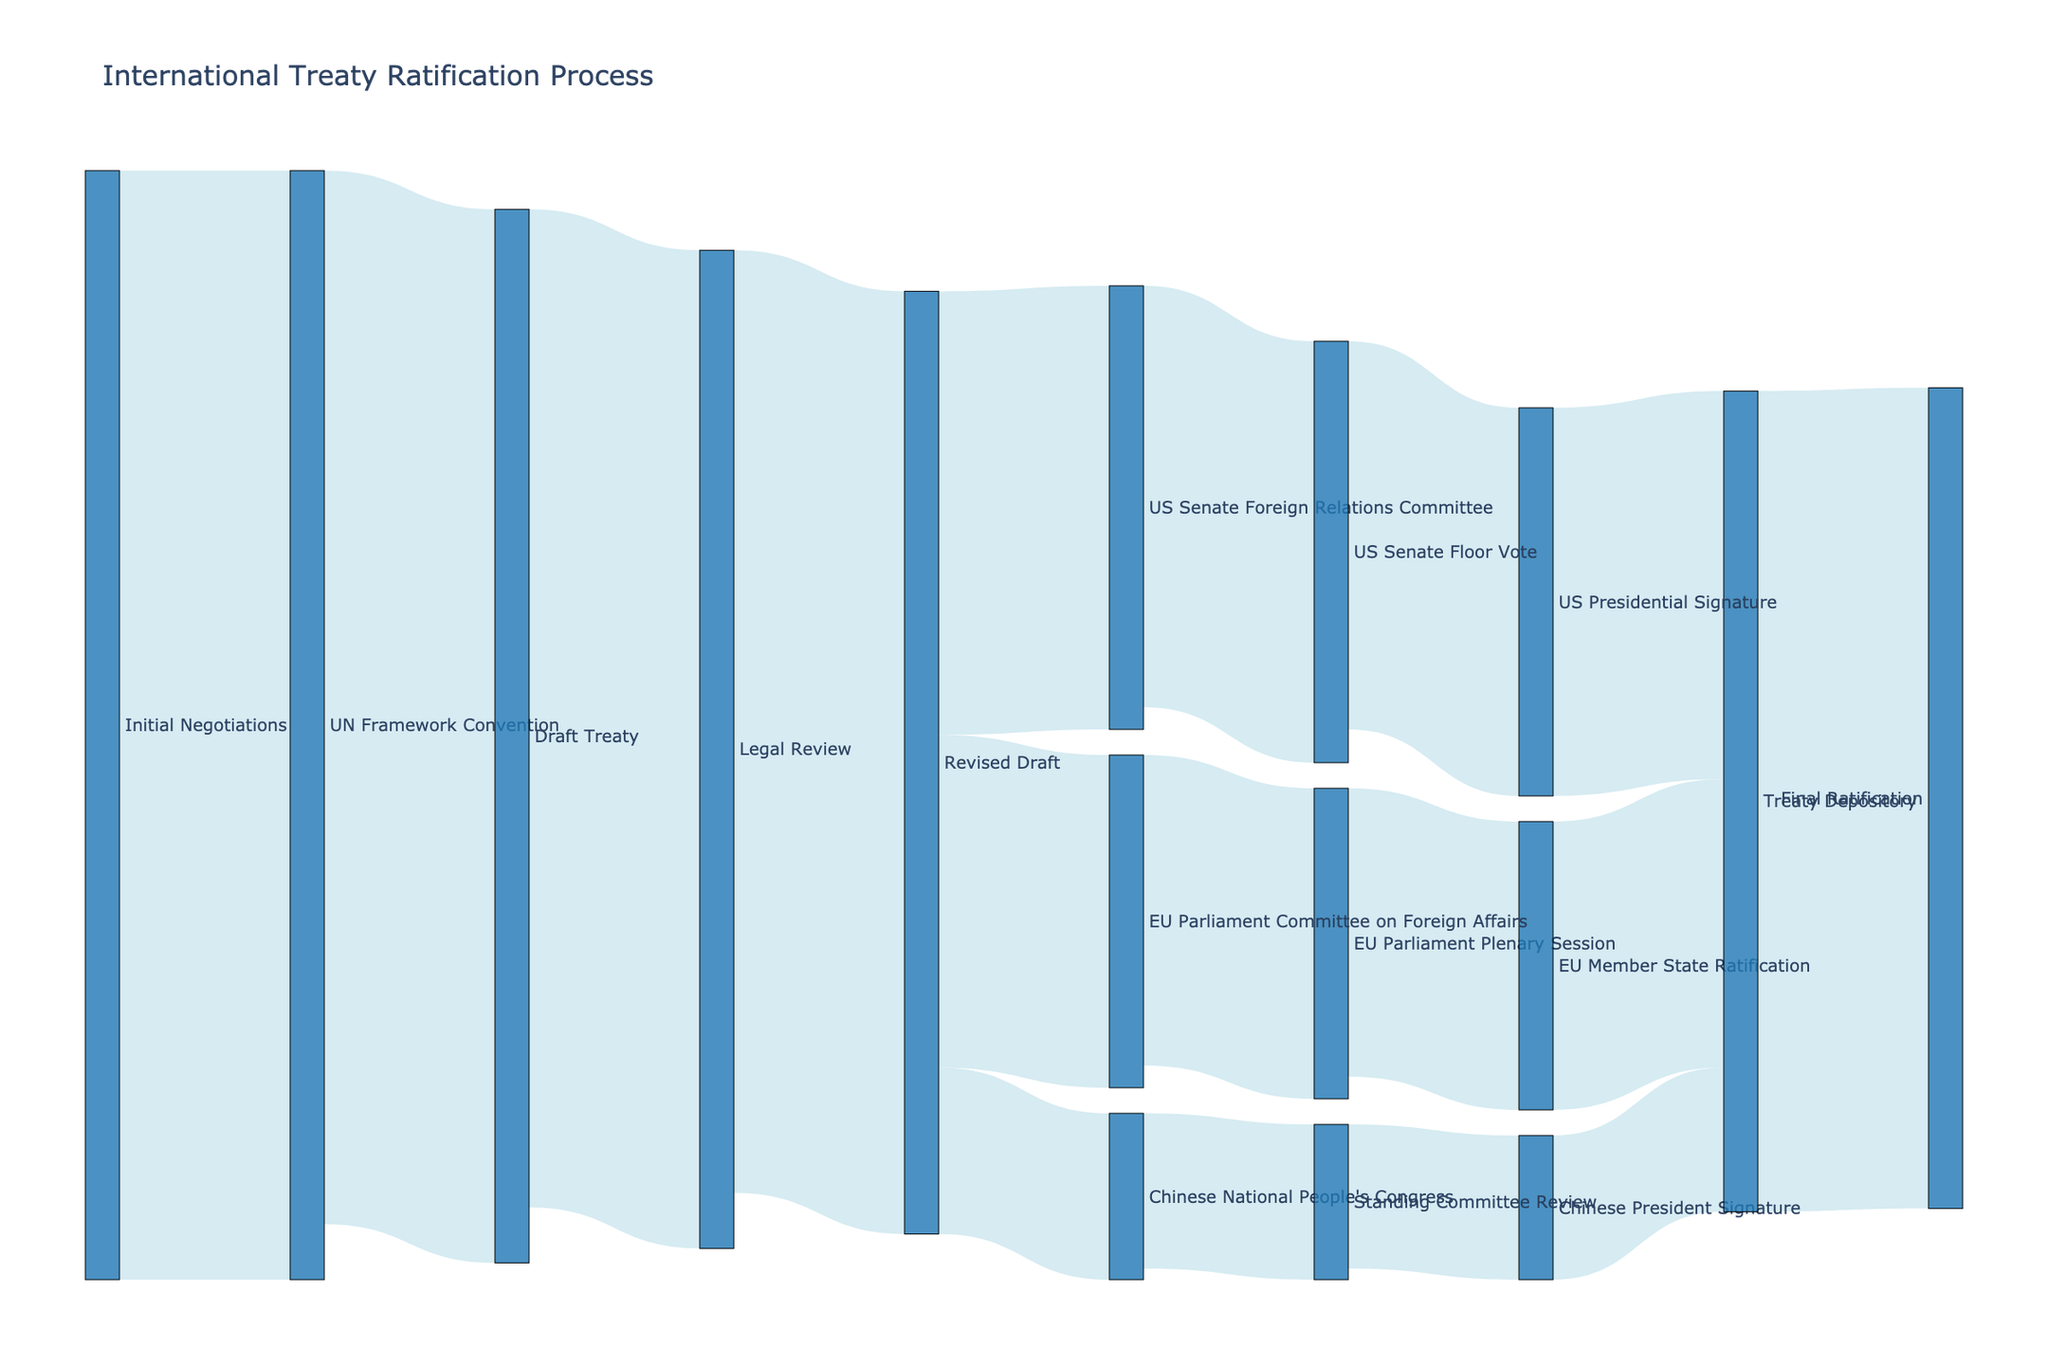What is the title of the Sankey Diagram? The title of the Sankey Diagram is displayed at the top of the diagram, which indicates the main topic it covers. In this case, it represents the process being analyzed in the figure.
Answer: International Treaty Ratification Process Which node has the highest value in the flow from the 'Initial Negotiations' phase? To determine this, look at the connections originating from 'Initial Negotiations' and follow the thickness or value along the path. The value of 100 marks this node as the highest in its initial phase.
Answer: UN Framework Convention What is the combined flow value from the 'Revised Draft' to 'US Senate Foreign Relations Committee', 'EU Parliament Committee on Foreign Affairs', and 'Chinese National People's Congress'? The combined flow value can be calculated by summing the individual values of the connections: 40 (US Senate) + 30 (EU Parliament) + 15 (Chinese Congress) = 85.
Answer: 85 Which country has the smallest flow value proceeding from their respective national committee to the final approval? To identify this, examine the values going from the national committees to final approval stages. The smallest value among US, EU, and China is from the Chinese National People's Congress at 14.
Answer: China How many unique nodes are present in the Sankey Diagram? To find this, count the distinct labels in both the source and target lists.
Answer: 16 What is the final ratification value of the treaty? Look at the terminal node labeled 'Final Ratification' and see the incoming value to that node. The value is directly mentioned as 74.
Answer: 74 What is the difference in value between 'US Presidential Signature' and 'EU Member State Ratification' before reaching the 'Treaty Depository'? Find the values of both nodes before they reach 'Treaty Depository'. For US, it's 35, and for the EU, it’s 26. Subtract these values: 35 - 26 = 9.
Answer: 9 From which stages does the 'Treaty Depository' receive values, and what are they? Identify all nodes that connect directly to the 'Treaty Depository' and list their values. The stages and their values leading into 'Treaty Depository' are 'US Presidential Signature' (35), 'EU Member State Ratification' (26), and 'Chinese President Signature' (13).
Answer: US Presidential Signature (35), EU Member State Ratification (26), Chinese President Signature (13) Which phase has the highest drop in value compared to its preceding phase in the process? Look at each phase's value in the flow and calculate the difference with its preceding phase. The largest drop occurs from 'Initial Negotiations' (100) to 'Draft Treaty' (95).
Answer: Draft Treaty How many connections are there leading directly into the 'Final Ratification' stage? Observe the diagram and count the direct strands pointing to the 'Final Ratification'. There is only one connection leading directly into it.
Answer: 1 